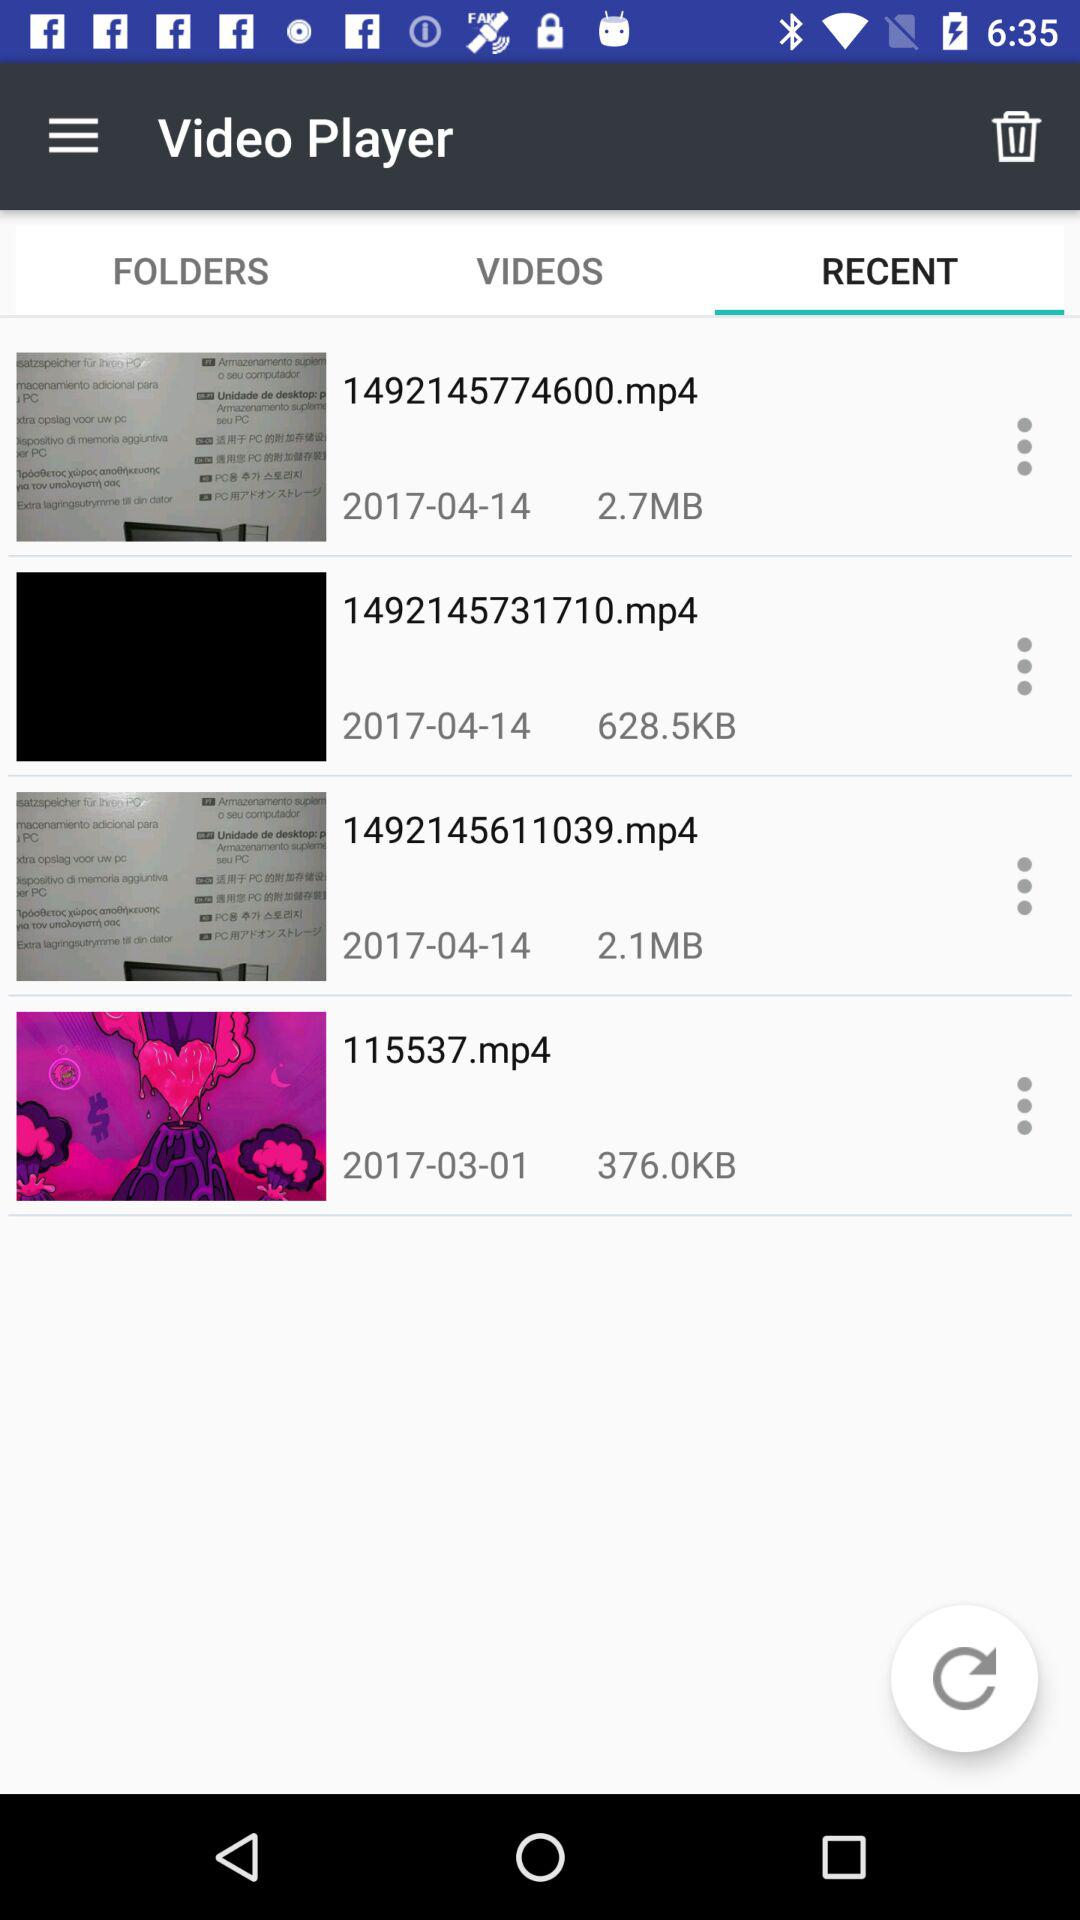How many videos are there in the Recent tab that are larger than 2MB?
Answer the question using a single word or phrase. 2 